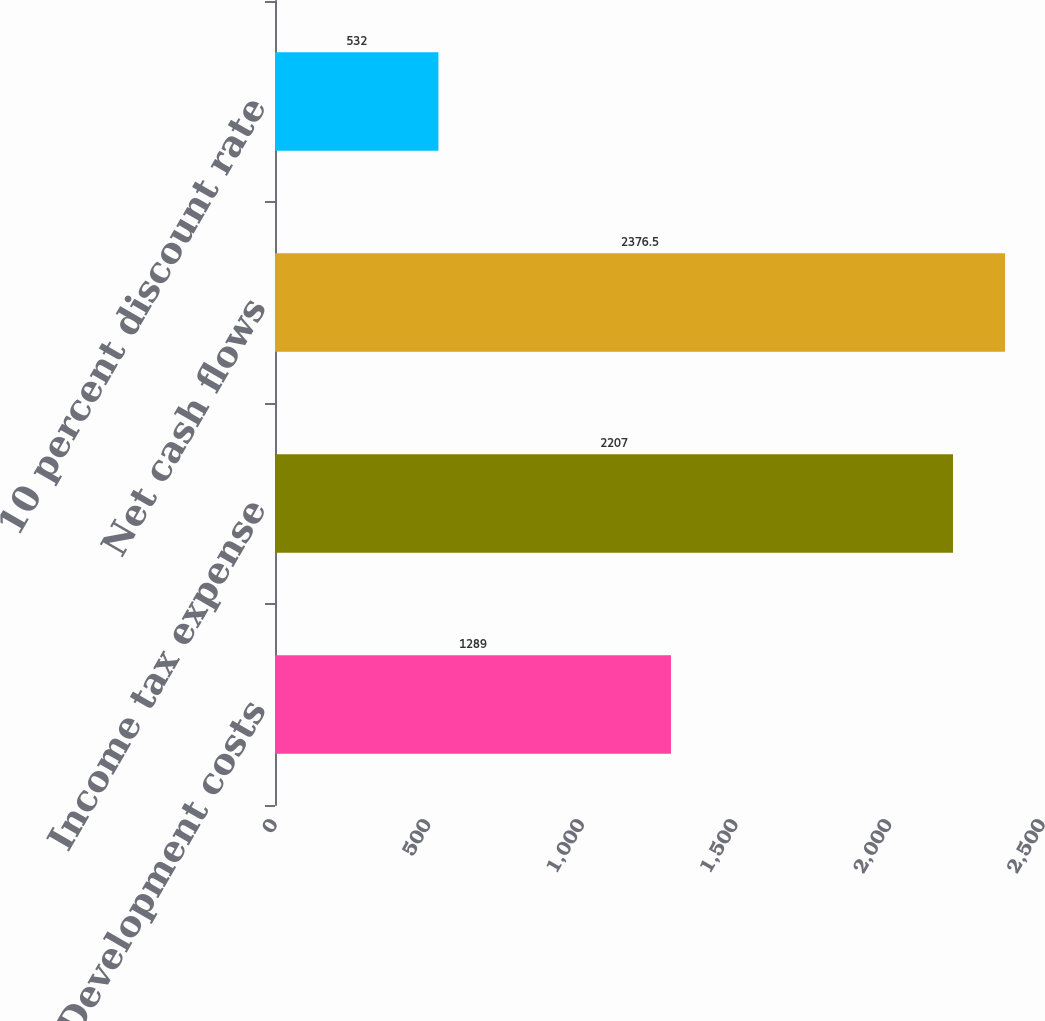Convert chart. <chart><loc_0><loc_0><loc_500><loc_500><bar_chart><fcel>Development costs<fcel>Income tax expense<fcel>Net cash flows<fcel>10 percent discount rate<nl><fcel>1289<fcel>2207<fcel>2376.5<fcel>532<nl></chart> 